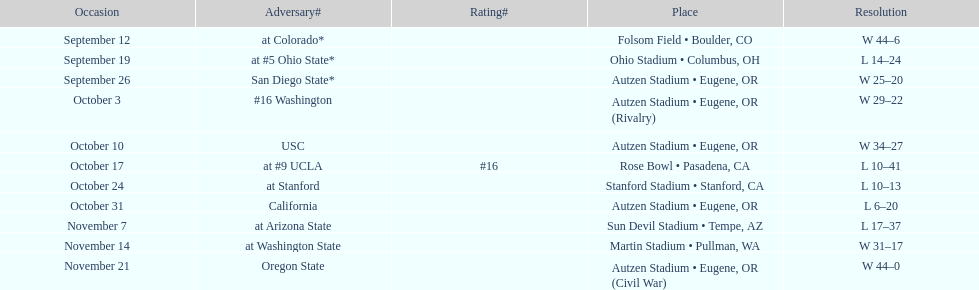What is the number of away games ? 6. 